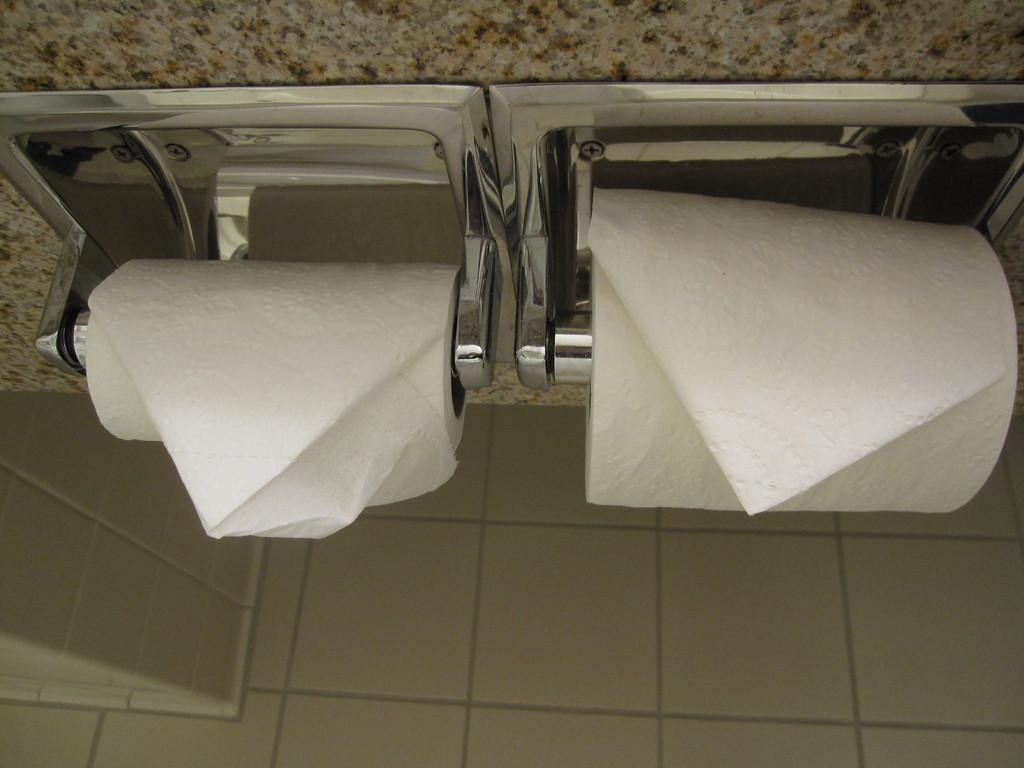In one or two sentences, can you explain what this image depicts? In this image, we can see tissues and holders and there is a wall. At the bottom, there is a floor. 